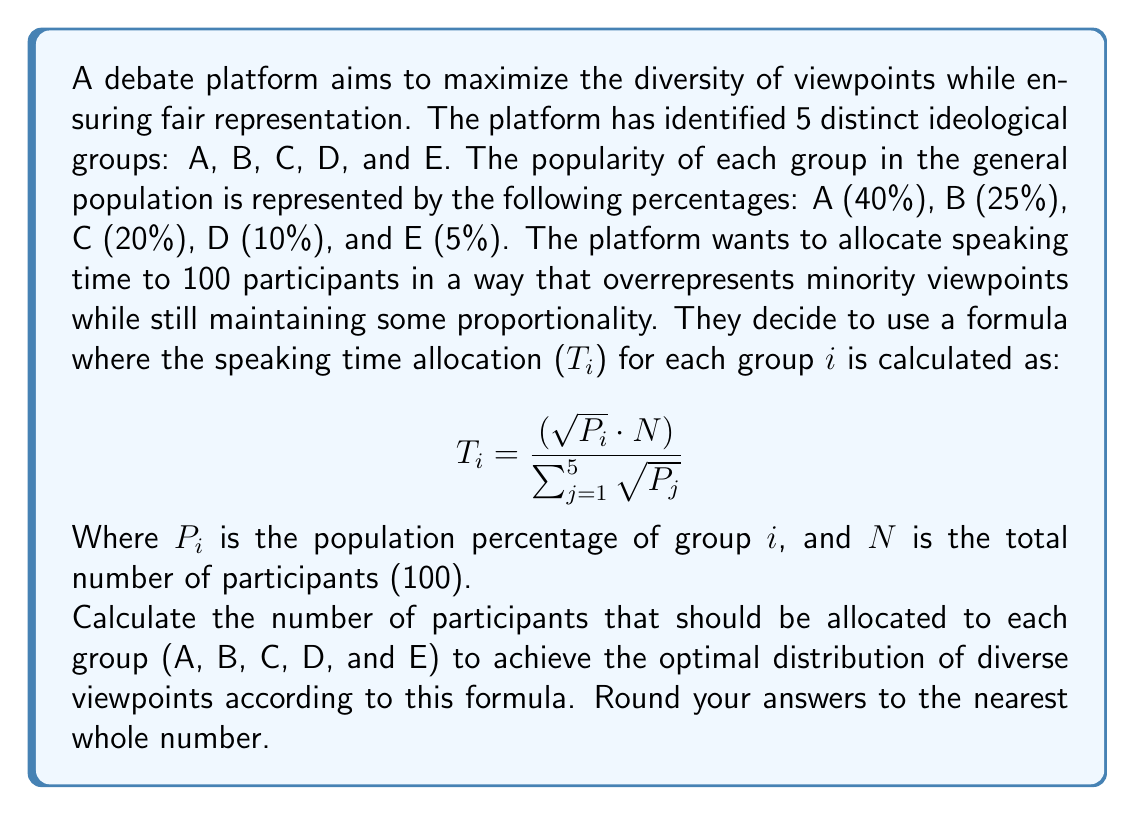Provide a solution to this math problem. To solve this problem, we'll follow these steps:

1. Calculate $\sqrt{P_i}$ for each group.
2. Sum up all $\sqrt{P_i}$ values.
3. Apply the formula for each group.
4. Round the results to the nearest whole number.

Step 1: Calculate $\sqrt{P_i}$ for each group
* Group A: $\sqrt{0.40} \approx 0.6325$
* Group B: $\sqrt{0.25} = 0.5000$
* Group C: $\sqrt{0.20} \approx 0.4472$
* Group D: $\sqrt{0.10} \approx 0.3162$
* Group E: $\sqrt{0.05} \approx 0.2236$

Step 2: Sum up all $\sqrt{P_i}$ values
$$\sum_{j=1}^{5} \sqrt{P_j} \approx 0.6325 + 0.5000 + 0.4472 + 0.3162 + 0.2236 = 2.1195$$

Step 3: Apply the formula for each group
* Group A: $T_A = \frac{0.6325 \cdot 100}{2.1195} \approx 29.84$
* Group B: $T_B = \frac{0.5000 \cdot 100}{2.1195} \approx 23.59$
* Group C: $T_C = \frac{0.4472 \cdot 100}{2.1195} \approx 21.10$
* Group D: $T_D = \frac{0.3162 \cdot 100}{2.1195} \approx 14.92$
* Group E: $T_E = \frac{0.2236 \cdot 100}{2.1195} \approx 10.55$

Step 4: Round the results to the nearest whole number
* Group A: 30
* Group B: 24
* Group C: 21
* Group D: 15
* Group E: 11

This distribution ensures that minority viewpoints (groups D and E) are given more representation than their population percentages would suggest, while still maintaining a degree of proportionality with the larger groups.
Answer: The optimal distribution of participants for each group:
A: 30, B: 24, C: 21, D: 15, E: 11 